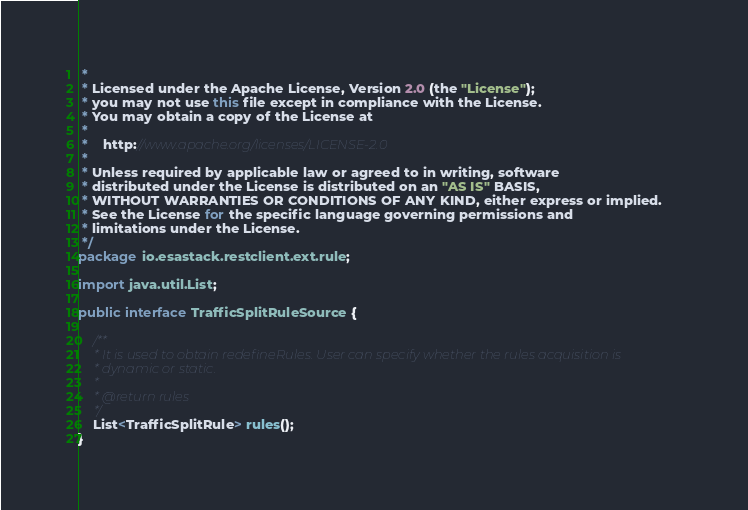<code> <loc_0><loc_0><loc_500><loc_500><_Java_> *
 * Licensed under the Apache License, Version 2.0 (the "License");
 * you may not use this file except in compliance with the License.
 * You may obtain a copy of the License at
 *
 *    http://www.apache.org/licenses/LICENSE-2.0
 *
 * Unless required by applicable law or agreed to in writing, software
 * distributed under the License is distributed on an "AS IS" BASIS,
 * WITHOUT WARRANTIES OR CONDITIONS OF ANY KIND, either express or implied.
 * See the License for the specific language governing permissions and
 * limitations under the License.
 */
package io.esastack.restclient.ext.rule;

import java.util.List;

public interface TrafficSplitRuleSource {

    /**
     * It is used to obtain redefineRules. User can specify whether the rules acquisition is
     * dynamic or static.
     *
     * @return rules
     */
    List<TrafficSplitRule> rules();
}
</code> 